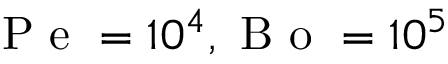Convert formula to latex. <formula><loc_0><loc_0><loc_500><loc_500>P e = 1 0 ^ { 4 } , B o = 1 0 ^ { 5 }</formula> 